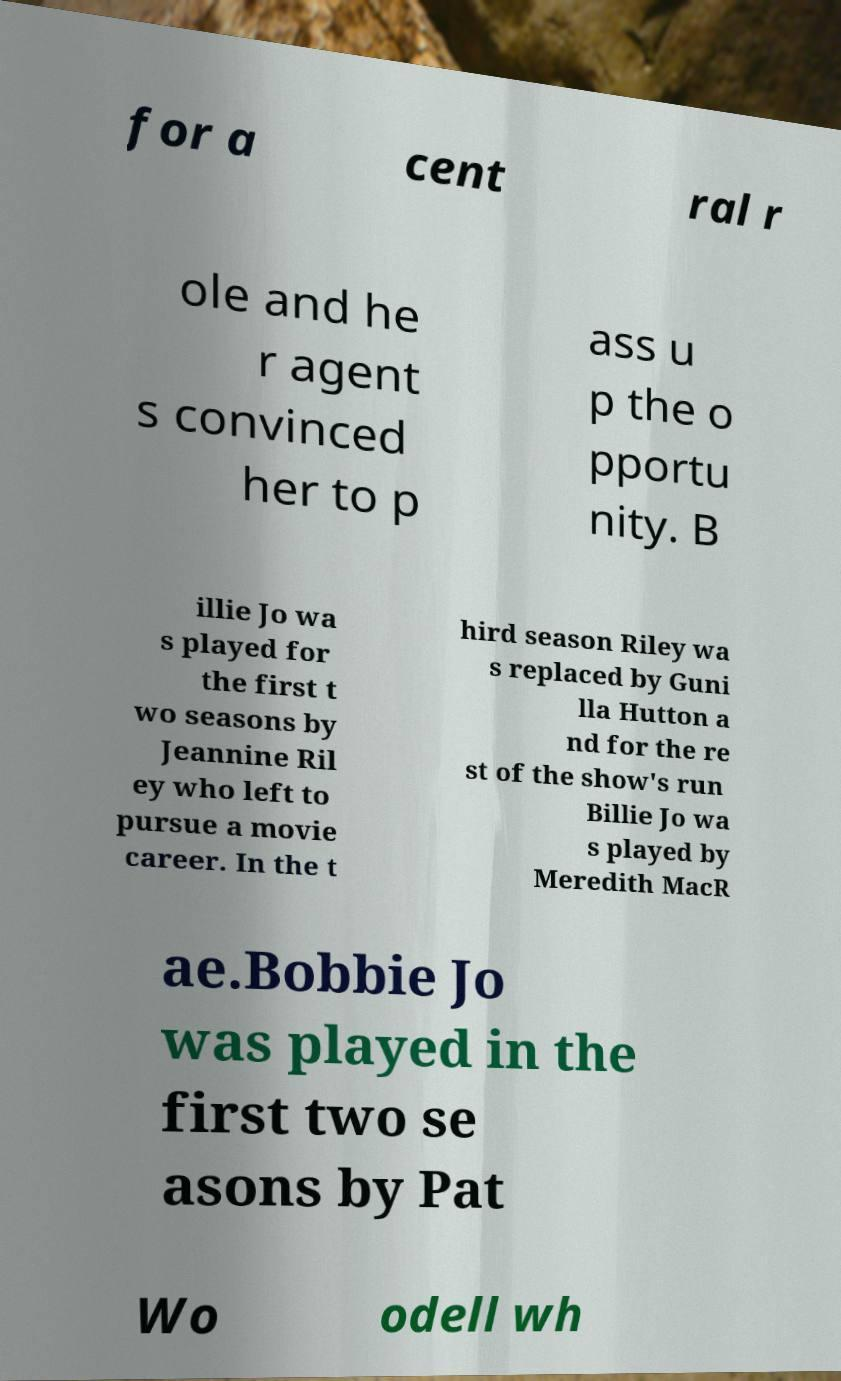Please identify and transcribe the text found in this image. for a cent ral r ole and he r agent s convinced her to p ass u p the o pportu nity. B illie Jo wa s played for the first t wo seasons by Jeannine Ril ey who left to pursue a movie career. In the t hird season Riley wa s replaced by Guni lla Hutton a nd for the re st of the show's run Billie Jo wa s played by Meredith MacR ae.Bobbie Jo was played in the first two se asons by Pat Wo odell wh 